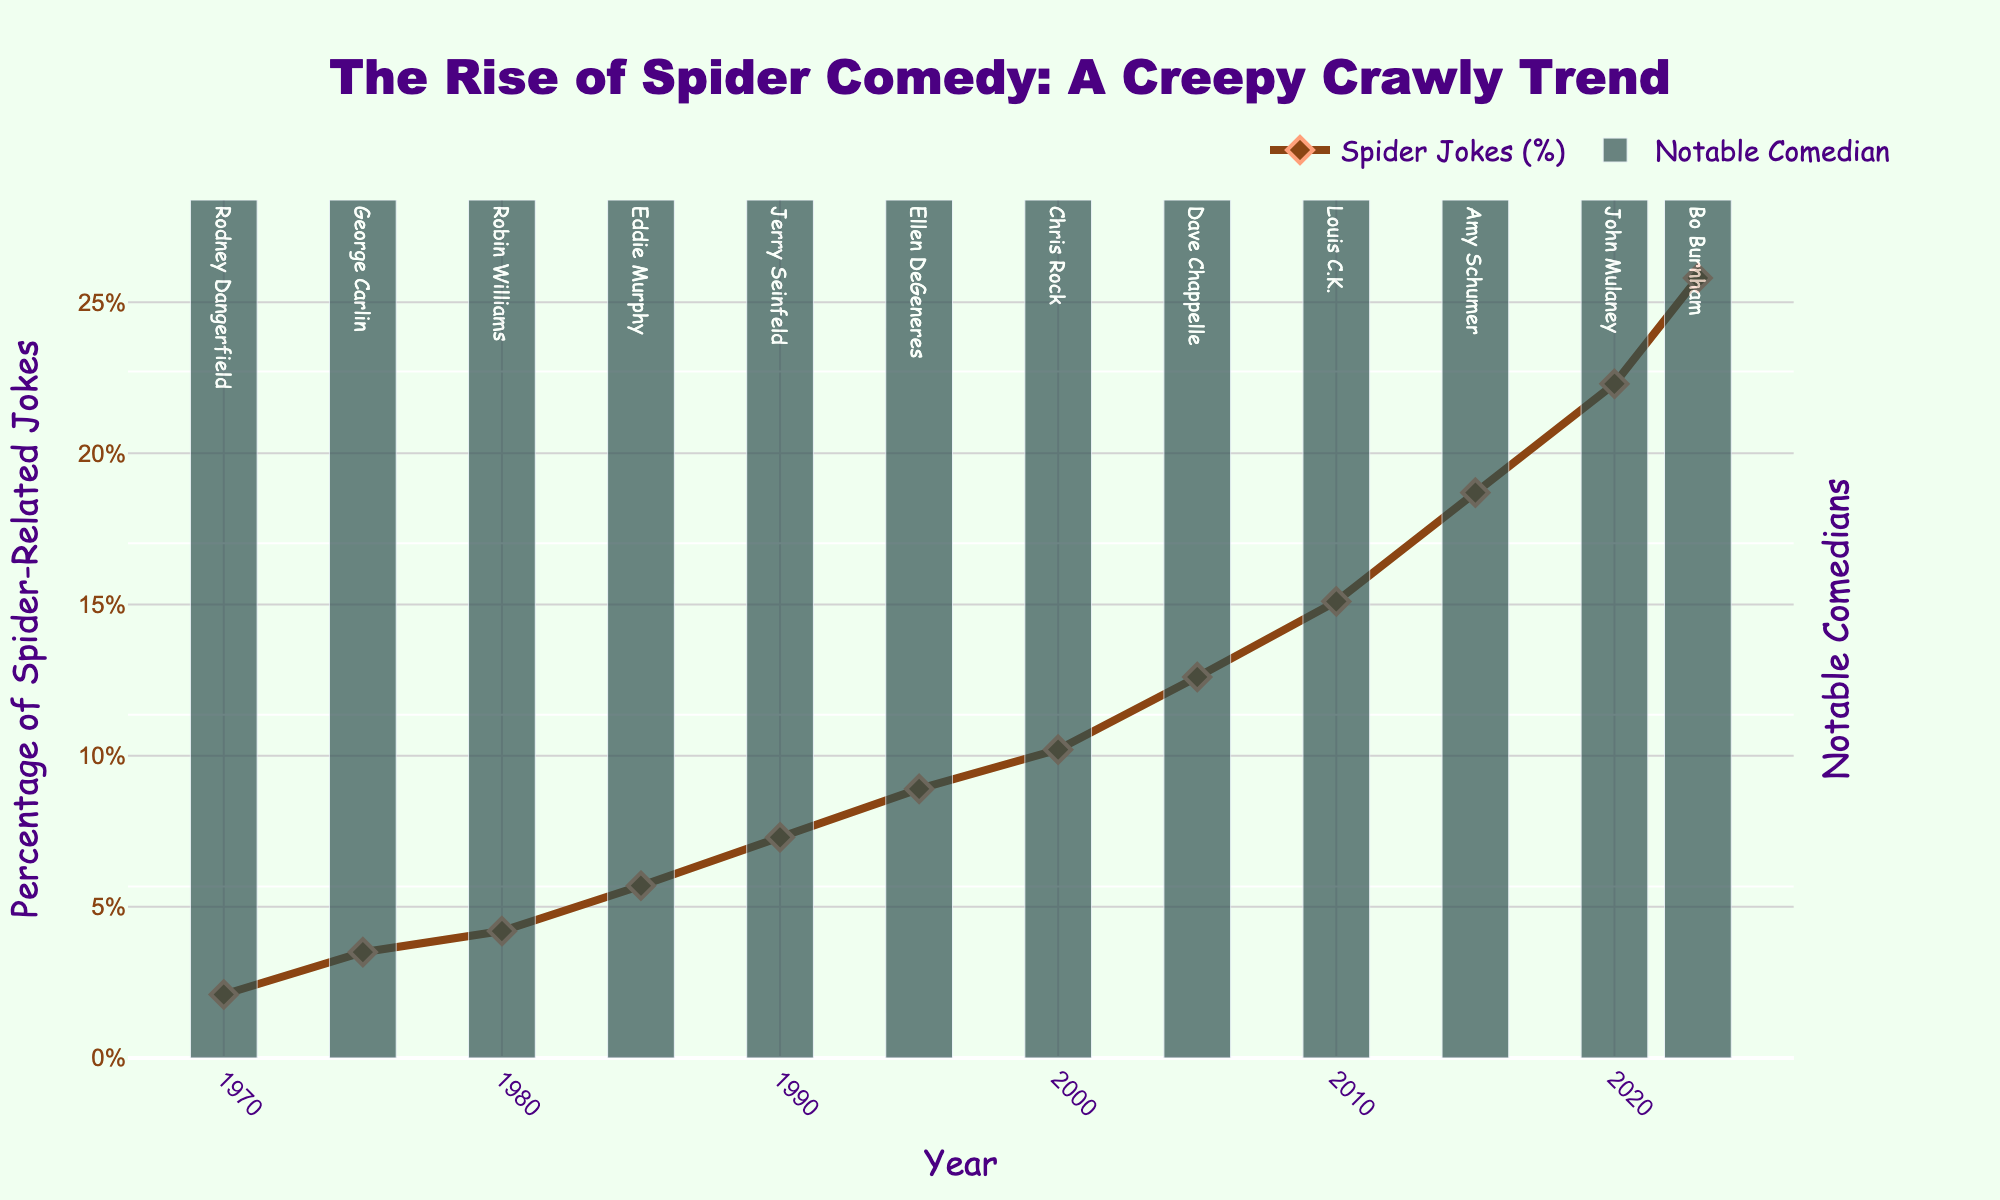What's the trend in the percentage of spider-related jokes between 1970 and 2023? From 1970 to 2023, the percentage of spider-related jokes has increased steadily, starting from 2.1% in 1970 and reaching 25.8% in 2023.
Answer: The trend is an increase Which year had the highest percentage of spider-related jokes? By looking at the figure, the year 2023 has the highest percentage of spider-related jokes at 25.8%.
Answer: 2023 Compare the percentage of spider-related jokes in 1985 and 2020. Which year had a higher percentage? By comparing the percentages, 1985 had 5.7% while 2020 had 22.3%. Hence, 2020 had a higher percentage of spider-related jokes.
Answer: 2020 How many years saw the percentage of spider-related jokes increase by more than 3% compared to the previous year? To find this, look at the year-over-year differences and note which ones are greater than 3%: 1985 vs 1980 (1.5%), 1990 vs 1985 (1.6%), 1995 vs 1990 (1.6%), 2000 vs 1995 (1.3%), 2005 vs 2000 (2.4%), 2010 vs 2005 (2.5%), 2015 vs 2010 (3.6%), 2020 vs 2015 (3.6%), 2023 vs 2020 (3.5%). Only one period (2015-2010, 2020-2015, and 2023-2020) had increases greater than 3%.
Answer: 3 Which comedian's notable theme is related to 'Spider-Man parody' and in what year? Robin Williams is the comedian associated with the 'Spider-Man parody' theme, and this was in the year 1980.
Answer: Robin Williams, 1980 What's the average percentage of spider-related jokes from 1970 to 1990? The percentages for these years are 2.1%, 3.5%, 4.2%, 5.7%, and 7.3%. The sum is 22.8%. There are 5 data points. 22.8/5 = 4.56.
Answer: 4.56% What visual attribute represents notable comedians on the chart? Notable comedians are represented by bars that carry text labels with comedians' names inside them.
Answer: Bars with comedian names inside Determine the percentage difference in spider-related jokes between the years 2000 and 2023. To find the percentage difference, subtract the percentage of 2000 from the percentage of 2023 (25.8% - 10.2% = 15.6%).
Answer: 15.6% Describe the percentage trend between the years 2005 and 2010 and explain how it compares to the trend from 2010 to 2015. From 2005 to 2010, the percentage increased from 12.6% to 15.1% (a 2.5% increase). From 2010 to 2015, it increased from 15.1% to 18.7% (a 3.6% increase). The later period saw a larger increase.
Answer: Larger increase from 2010 to 2015 